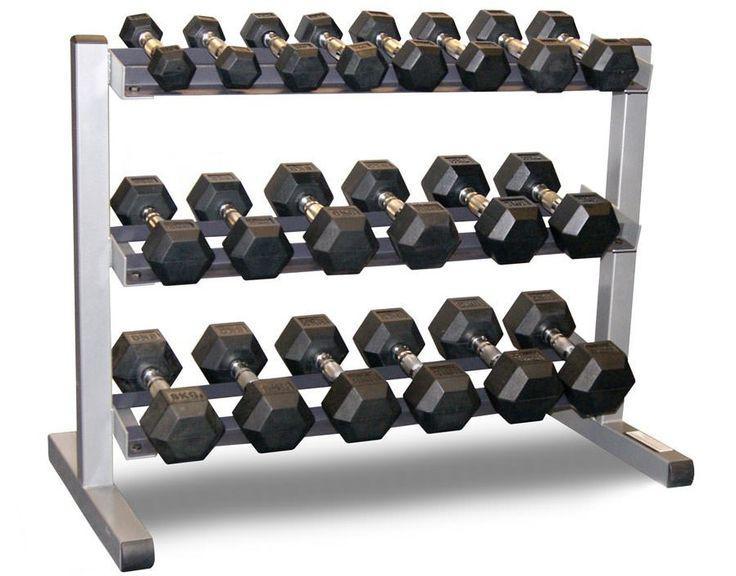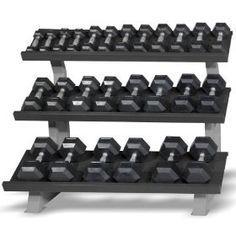The first image is the image on the left, the second image is the image on the right. For the images displayed, is the sentence "The weights sitting in the rack in the image on the left are round in shape." factually correct? Answer yes or no. No. The first image is the image on the left, the second image is the image on the right. For the images shown, is this caption "Left and right racks hold three rows of dumbbells, and dumbbells have the same end shapes in both images." true? Answer yes or no. Yes. 